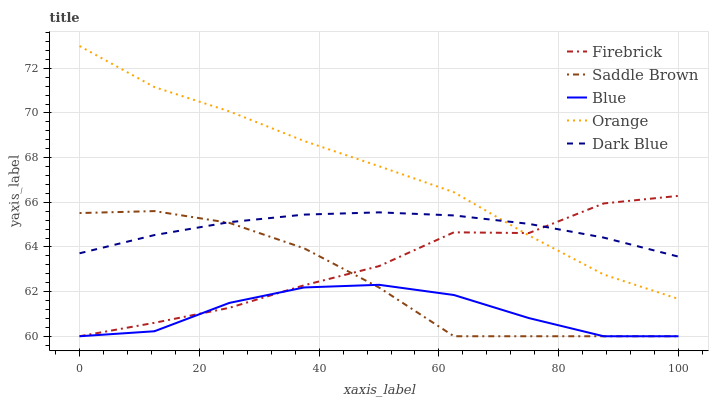Does Blue have the minimum area under the curve?
Answer yes or no. Yes. Does Orange have the maximum area under the curve?
Answer yes or no. Yes. Does Firebrick have the minimum area under the curve?
Answer yes or no. No. Does Firebrick have the maximum area under the curve?
Answer yes or no. No. Is Dark Blue the smoothest?
Answer yes or no. Yes. Is Firebrick the roughest?
Answer yes or no. Yes. Is Orange the smoothest?
Answer yes or no. No. Is Orange the roughest?
Answer yes or no. No. Does Orange have the lowest value?
Answer yes or no. No. Does Orange have the highest value?
Answer yes or no. Yes. Does Firebrick have the highest value?
Answer yes or no. No. Is Blue less than Orange?
Answer yes or no. Yes. Is Orange greater than Saddle Brown?
Answer yes or no. Yes. Does Orange intersect Firebrick?
Answer yes or no. Yes. Is Orange less than Firebrick?
Answer yes or no. No. Is Orange greater than Firebrick?
Answer yes or no. No. Does Blue intersect Orange?
Answer yes or no. No. 